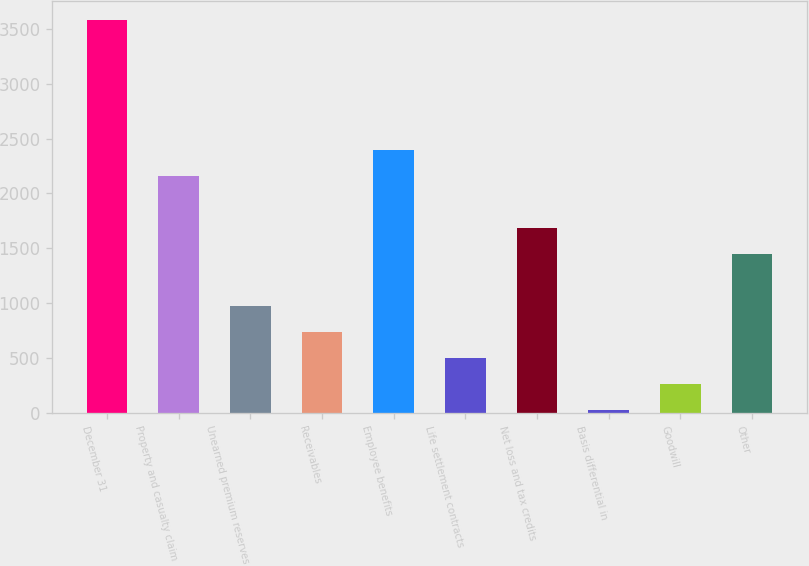Convert chart to OTSL. <chart><loc_0><loc_0><loc_500><loc_500><bar_chart><fcel>December 31<fcel>Property and casualty claim<fcel>Unearned premium reserves<fcel>Receivables<fcel>Employee benefits<fcel>Life settlement contracts<fcel>Net loss and tax credits<fcel>Basis differential in<fcel>Goodwill<fcel>Other<nl><fcel>3578<fcel>2157.2<fcel>973.2<fcel>736.4<fcel>2394<fcel>499.6<fcel>1683.6<fcel>26<fcel>262.8<fcel>1446.8<nl></chart> 